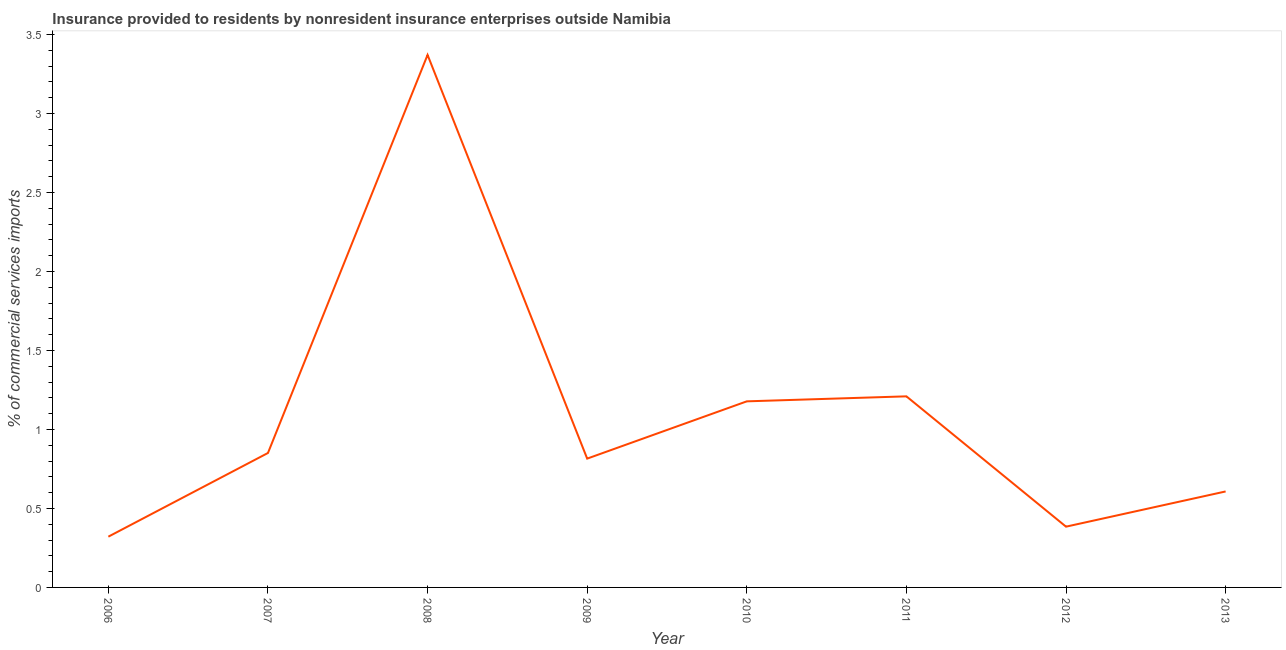What is the insurance provided by non-residents in 2009?
Your answer should be very brief. 0.82. Across all years, what is the maximum insurance provided by non-residents?
Provide a short and direct response. 3.37. Across all years, what is the minimum insurance provided by non-residents?
Offer a terse response. 0.32. In which year was the insurance provided by non-residents minimum?
Offer a very short reply. 2006. What is the sum of the insurance provided by non-residents?
Your answer should be compact. 8.74. What is the difference between the insurance provided by non-residents in 2009 and 2012?
Your response must be concise. 0.43. What is the average insurance provided by non-residents per year?
Your answer should be very brief. 1.09. What is the median insurance provided by non-residents?
Provide a short and direct response. 0.83. In how many years, is the insurance provided by non-residents greater than 2.5 %?
Your answer should be compact. 1. What is the ratio of the insurance provided by non-residents in 2009 to that in 2010?
Offer a terse response. 0.69. Is the insurance provided by non-residents in 2009 less than that in 2011?
Your answer should be compact. Yes. What is the difference between the highest and the second highest insurance provided by non-residents?
Your answer should be very brief. 2.16. Is the sum of the insurance provided by non-residents in 2007 and 2012 greater than the maximum insurance provided by non-residents across all years?
Your response must be concise. No. What is the difference between the highest and the lowest insurance provided by non-residents?
Ensure brevity in your answer.  3.05. In how many years, is the insurance provided by non-residents greater than the average insurance provided by non-residents taken over all years?
Provide a succinct answer. 3. How many lines are there?
Offer a very short reply. 1. How many years are there in the graph?
Your answer should be very brief. 8. Are the values on the major ticks of Y-axis written in scientific E-notation?
Offer a terse response. No. What is the title of the graph?
Your response must be concise. Insurance provided to residents by nonresident insurance enterprises outside Namibia. What is the label or title of the X-axis?
Keep it short and to the point. Year. What is the label or title of the Y-axis?
Offer a very short reply. % of commercial services imports. What is the % of commercial services imports in 2006?
Make the answer very short. 0.32. What is the % of commercial services imports in 2007?
Provide a succinct answer. 0.85. What is the % of commercial services imports in 2008?
Offer a very short reply. 3.37. What is the % of commercial services imports of 2009?
Provide a short and direct response. 0.82. What is the % of commercial services imports in 2010?
Keep it short and to the point. 1.18. What is the % of commercial services imports in 2011?
Provide a succinct answer. 1.21. What is the % of commercial services imports in 2012?
Your response must be concise. 0.38. What is the % of commercial services imports in 2013?
Make the answer very short. 0.61. What is the difference between the % of commercial services imports in 2006 and 2007?
Your answer should be compact. -0.53. What is the difference between the % of commercial services imports in 2006 and 2008?
Make the answer very short. -3.05. What is the difference between the % of commercial services imports in 2006 and 2009?
Offer a very short reply. -0.49. What is the difference between the % of commercial services imports in 2006 and 2010?
Give a very brief answer. -0.86. What is the difference between the % of commercial services imports in 2006 and 2011?
Give a very brief answer. -0.89. What is the difference between the % of commercial services imports in 2006 and 2012?
Offer a terse response. -0.06. What is the difference between the % of commercial services imports in 2006 and 2013?
Your response must be concise. -0.29. What is the difference between the % of commercial services imports in 2007 and 2008?
Your response must be concise. -2.52. What is the difference between the % of commercial services imports in 2007 and 2009?
Make the answer very short. 0.04. What is the difference between the % of commercial services imports in 2007 and 2010?
Your answer should be compact. -0.33. What is the difference between the % of commercial services imports in 2007 and 2011?
Keep it short and to the point. -0.36. What is the difference between the % of commercial services imports in 2007 and 2012?
Offer a very short reply. 0.47. What is the difference between the % of commercial services imports in 2007 and 2013?
Offer a very short reply. 0.24. What is the difference between the % of commercial services imports in 2008 and 2009?
Offer a very short reply. 2.55. What is the difference between the % of commercial services imports in 2008 and 2010?
Offer a very short reply. 2.19. What is the difference between the % of commercial services imports in 2008 and 2011?
Keep it short and to the point. 2.16. What is the difference between the % of commercial services imports in 2008 and 2012?
Offer a terse response. 2.99. What is the difference between the % of commercial services imports in 2008 and 2013?
Offer a terse response. 2.76. What is the difference between the % of commercial services imports in 2009 and 2010?
Offer a terse response. -0.36. What is the difference between the % of commercial services imports in 2009 and 2011?
Your answer should be compact. -0.39. What is the difference between the % of commercial services imports in 2009 and 2012?
Offer a terse response. 0.43. What is the difference between the % of commercial services imports in 2009 and 2013?
Give a very brief answer. 0.21. What is the difference between the % of commercial services imports in 2010 and 2011?
Offer a terse response. -0.03. What is the difference between the % of commercial services imports in 2010 and 2012?
Offer a terse response. 0.79. What is the difference between the % of commercial services imports in 2010 and 2013?
Offer a terse response. 0.57. What is the difference between the % of commercial services imports in 2011 and 2012?
Keep it short and to the point. 0.82. What is the difference between the % of commercial services imports in 2011 and 2013?
Give a very brief answer. 0.6. What is the difference between the % of commercial services imports in 2012 and 2013?
Give a very brief answer. -0.22. What is the ratio of the % of commercial services imports in 2006 to that in 2007?
Offer a very short reply. 0.38. What is the ratio of the % of commercial services imports in 2006 to that in 2008?
Provide a succinct answer. 0.1. What is the ratio of the % of commercial services imports in 2006 to that in 2009?
Keep it short and to the point. 0.39. What is the ratio of the % of commercial services imports in 2006 to that in 2010?
Your answer should be compact. 0.27. What is the ratio of the % of commercial services imports in 2006 to that in 2011?
Your response must be concise. 0.27. What is the ratio of the % of commercial services imports in 2006 to that in 2012?
Your answer should be compact. 0.83. What is the ratio of the % of commercial services imports in 2006 to that in 2013?
Your answer should be compact. 0.53. What is the ratio of the % of commercial services imports in 2007 to that in 2008?
Make the answer very short. 0.25. What is the ratio of the % of commercial services imports in 2007 to that in 2009?
Provide a succinct answer. 1.04. What is the ratio of the % of commercial services imports in 2007 to that in 2010?
Offer a terse response. 0.72. What is the ratio of the % of commercial services imports in 2007 to that in 2011?
Offer a terse response. 0.7. What is the ratio of the % of commercial services imports in 2007 to that in 2012?
Provide a succinct answer. 2.21. What is the ratio of the % of commercial services imports in 2007 to that in 2013?
Your answer should be very brief. 1.4. What is the ratio of the % of commercial services imports in 2008 to that in 2009?
Offer a very short reply. 4.13. What is the ratio of the % of commercial services imports in 2008 to that in 2010?
Your answer should be very brief. 2.86. What is the ratio of the % of commercial services imports in 2008 to that in 2011?
Your answer should be very brief. 2.79. What is the ratio of the % of commercial services imports in 2008 to that in 2012?
Your answer should be compact. 8.76. What is the ratio of the % of commercial services imports in 2008 to that in 2013?
Your answer should be compact. 5.55. What is the ratio of the % of commercial services imports in 2009 to that in 2010?
Offer a terse response. 0.69. What is the ratio of the % of commercial services imports in 2009 to that in 2011?
Offer a terse response. 0.67. What is the ratio of the % of commercial services imports in 2009 to that in 2012?
Make the answer very short. 2.12. What is the ratio of the % of commercial services imports in 2009 to that in 2013?
Offer a terse response. 1.34. What is the ratio of the % of commercial services imports in 2010 to that in 2012?
Give a very brief answer. 3.06. What is the ratio of the % of commercial services imports in 2010 to that in 2013?
Your answer should be compact. 1.94. What is the ratio of the % of commercial services imports in 2011 to that in 2012?
Your answer should be very brief. 3.15. What is the ratio of the % of commercial services imports in 2011 to that in 2013?
Provide a short and direct response. 1.99. What is the ratio of the % of commercial services imports in 2012 to that in 2013?
Your answer should be compact. 0.63. 